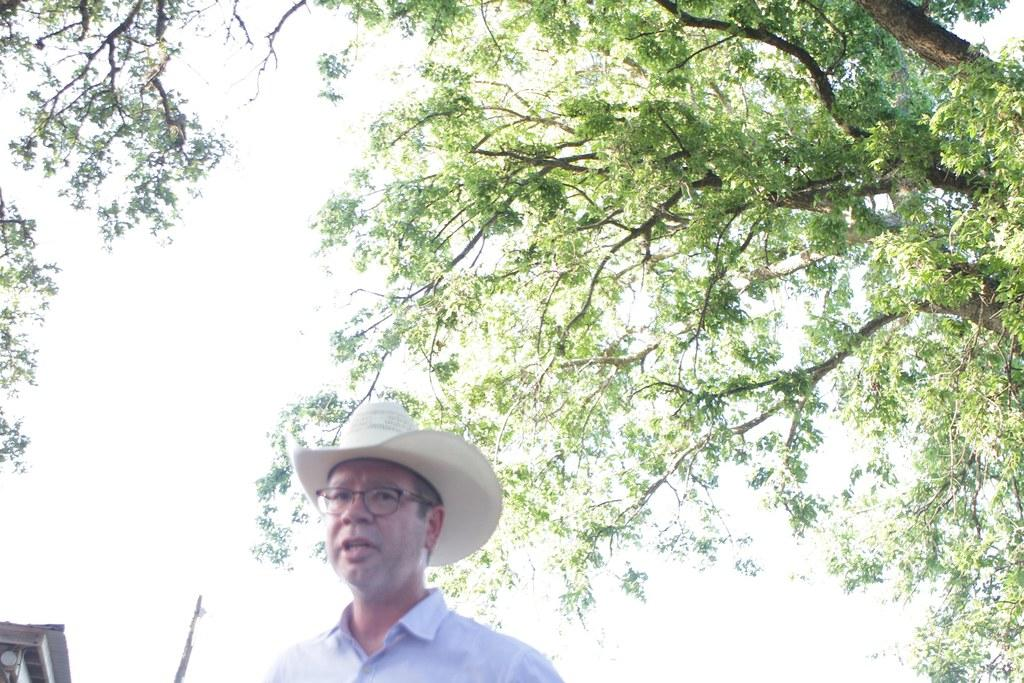Where was the image taken? The image was taken outside. Can you describe the person in the foreground of the image? There is a person in the foreground of the image, and they are wearing a blue shirt. What might the person be doing in the image? The person appears to be talking. What can be seen in the background of the image? There is a sky, a tree, and a building visible in the background of the image. How many hearts are hanging from the tree in the image? There are no hearts hanging from the tree in the image; it is a tree with leaves and branches. What type of can is visible in the image? There is no can present in the image. 